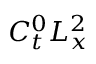<formula> <loc_0><loc_0><loc_500><loc_500>C _ { t } ^ { 0 } L _ { x } ^ { 2 }</formula> 